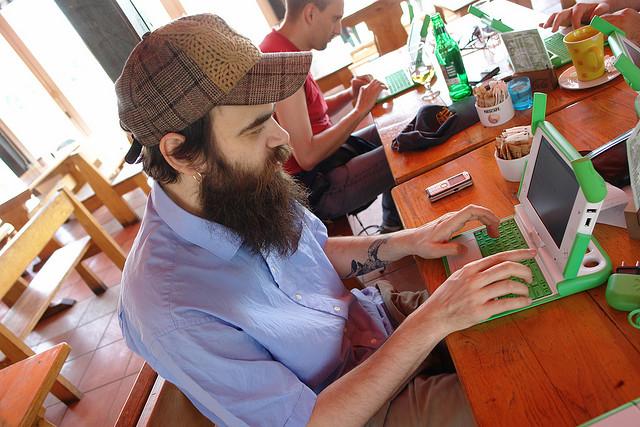Are the men wearing long sleeved shirts?
Give a very brief answer. No. Has this guy recently shaved?
Write a very short answer. No. What color are the devices the people are typing on?
Quick response, please. Green and white. 